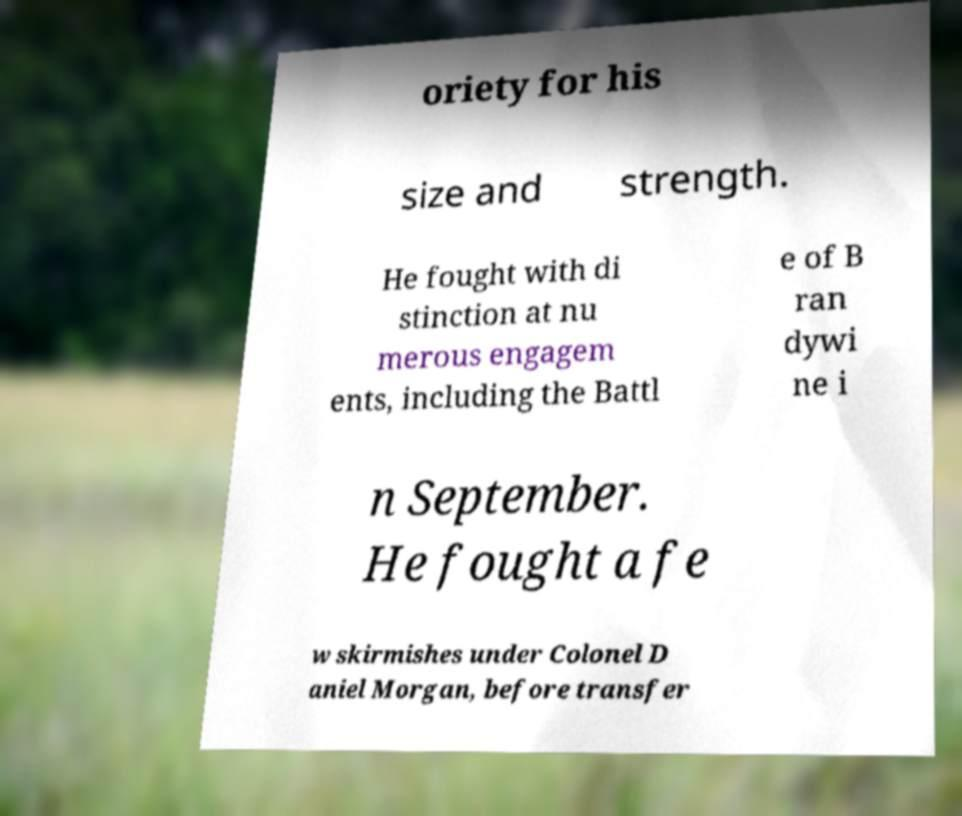Can you read and provide the text displayed in the image?This photo seems to have some interesting text. Can you extract and type it out for me? oriety for his size and strength. He fought with di stinction at nu merous engagem ents, including the Battl e of B ran dywi ne i n September. He fought a fe w skirmishes under Colonel D aniel Morgan, before transfer 